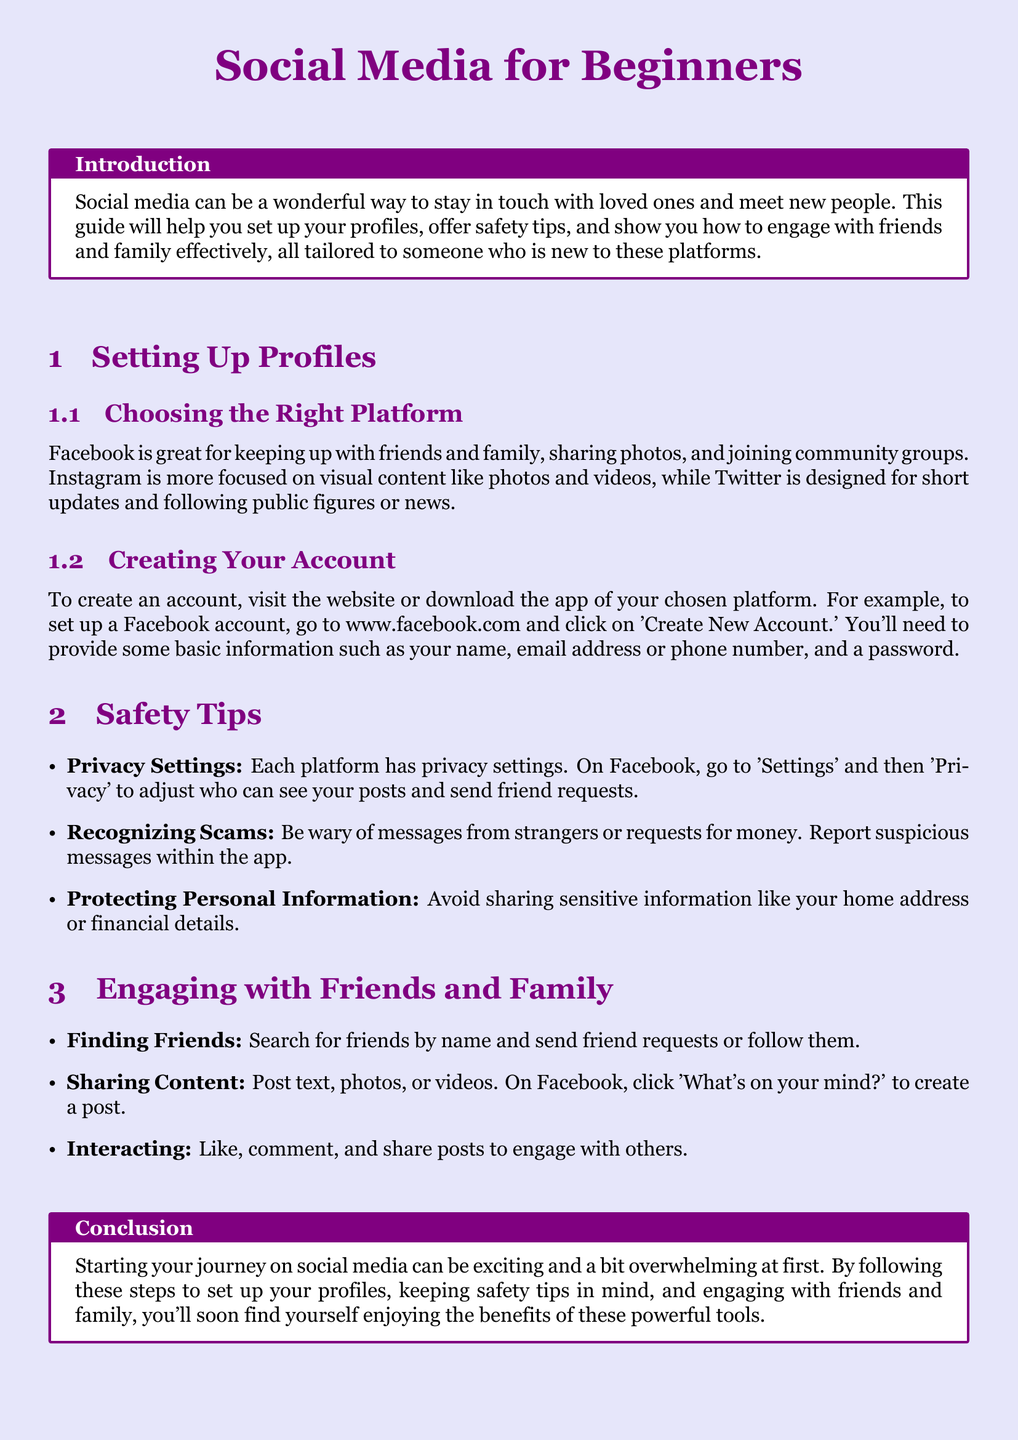What is the guide designed for? The guide is designed to help beginners with social media, including setting up profiles, safety tips, and engaging with friends and family.
Answer: beginners What platform is great for sharing photos? The document mentions that Instagram is more focused on visual content like photos and videos.
Answer: Instagram What is the first step to create a Facebook account? According to the document, you go to www.facebook.com and click on 'Create New Account.'
Answer: Create New Account What should you adjust in Facebook's settings for privacy? The document states that you should go to 'Settings' and then 'Privacy' to adjust who can see your posts.
Answer: Privacy What should you be wary of according to safety tips? The guide advises to be wary of messages from strangers or requests for money.
Answer: messages from strangers What can you do to interact with posts? It suggests liking, commenting, and sharing posts as ways to engage with others.
Answer: like, comment, and share What is the purpose of the conclusion in the document? The conclusion summarizes the guidance on starting social media and embracing its benefits.
Answer: summarize the guidance What do you find by searching for friends? This section mentions searching for friends by name and sending friend requests or following them.
Answer: sending friend requests 